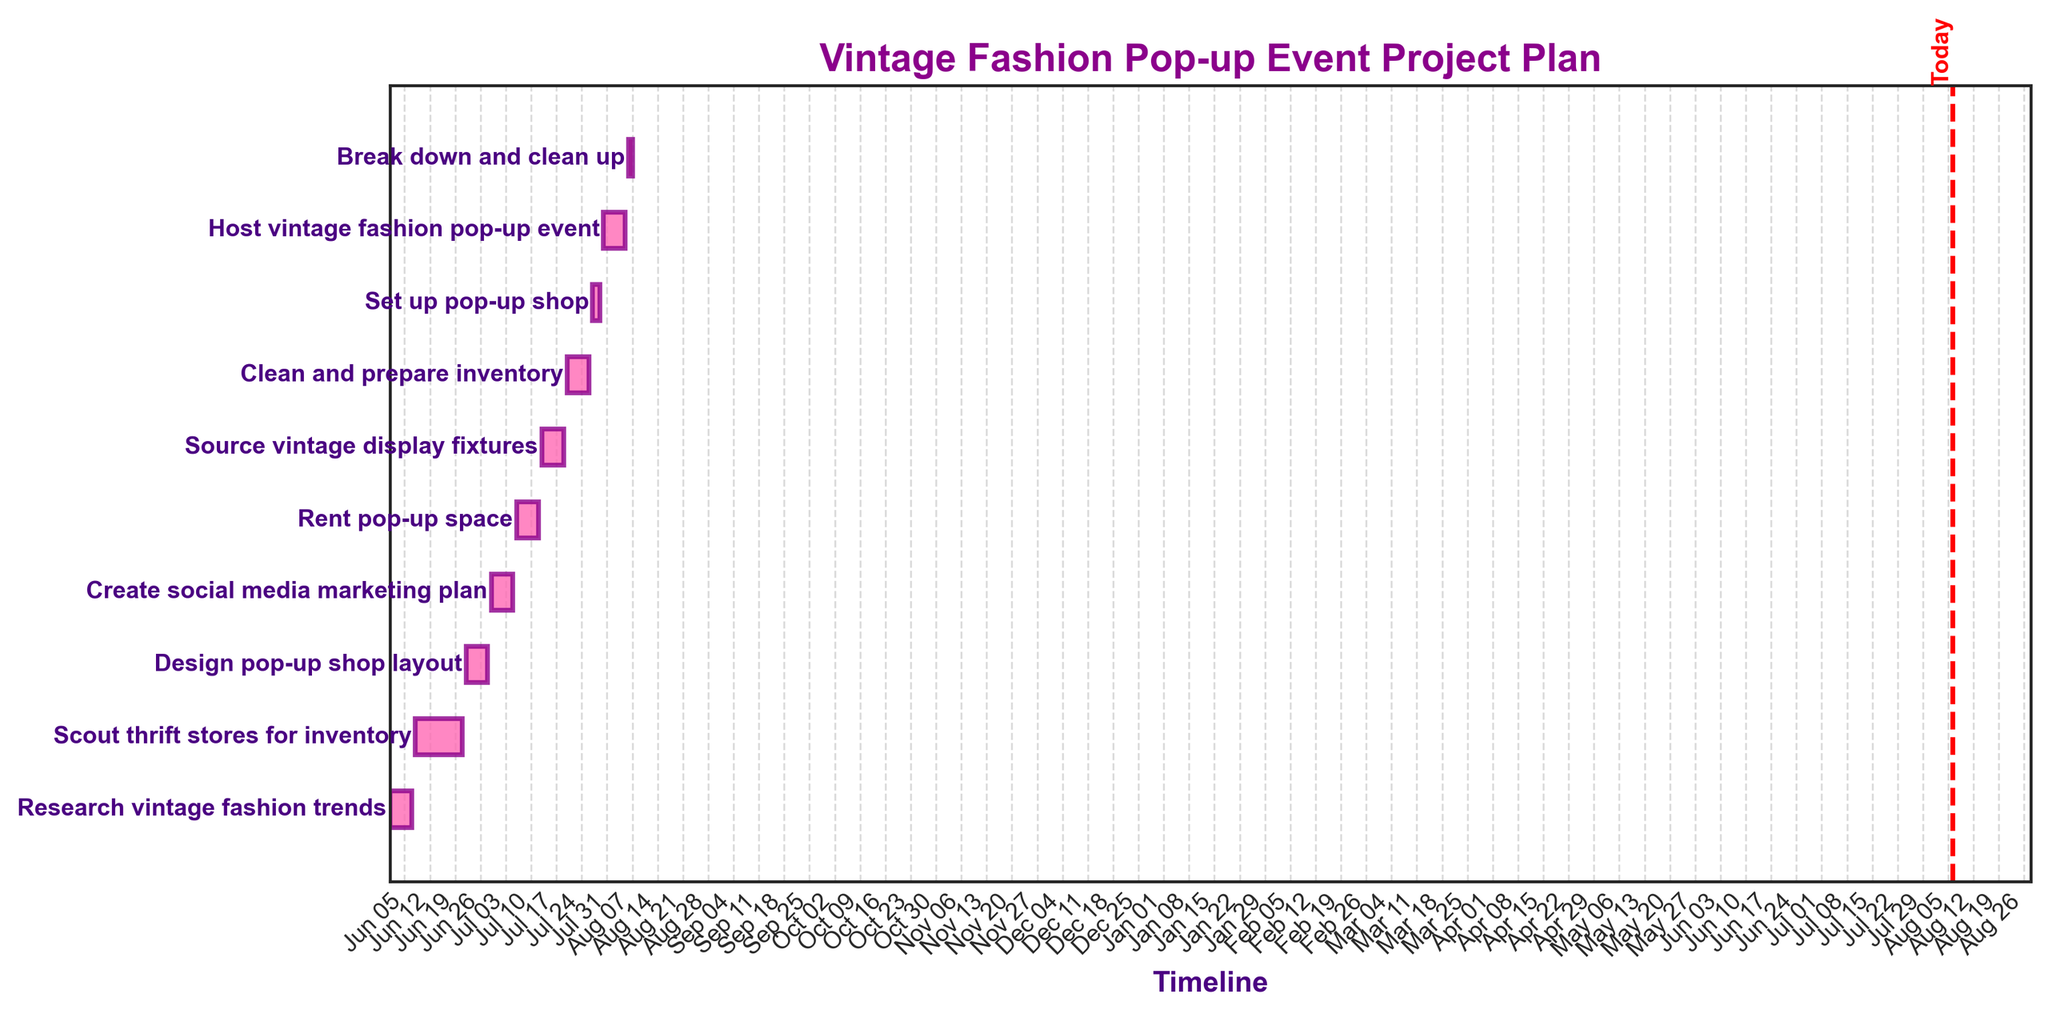What is the title of the chart? The title of the chart is located at the top and it clearly states the purpose of the Gantt chart.
Answer: Vintage Fashion Pop-up Event Project Plan How many total tasks are shown in the chart? By counting the number of horizontal bars in the Gantt chart, we can determine the total number of tasks involved in the project.
Answer: 10 Which task takes the longest duration to complete? By comparing the lengths of all the horizontal bars, we can see that "Scout thrift stores for inventory" spans the longest duration.
Answer: Scout thrift stores for inventory How many tasks have a duration of 7 days? By looking at the durations next to each task in the Gantt chart, we can count how many tasks are labeled with a duration of 7 days.
Answer: 6 What is the start and end date of the task "Set up pop-up shop"? By locating the "Set up pop-up shop" task in the chart, we can see its start date and end date on the horizontal timeline.
Answer: July 27 to July 29 Which two tasks are planned to be done simultaneously? By examining which horizontal bars overlap on the timeline, we can see that "Scout thrift stores for inventory" and "Design pop-up shop layout" partially overlap.
Answer: Scout thrift stores for inventory and Design pop-up shop layout How many days are included in the "Research vintage fashion trends" task? By analyzing the width of the bar corresponding to this task in the Gantt chart, we see that it starts on June 1 and ends on June 7, a total of 7 days.
Answer: 7 days What is the very last task to be completed according to the chart? By looking at the farthest right end of the Gantt chart, we can determine which task ends the latest.
Answer: Break down and clean up Which task ends just before the "Host vintage fashion pop-up event"? By examining the chart for the task that ends right before July 30, when the "Host vintage fashion pop-up event" starts, we find that "Set up pop-up shop" is the preceding task.
Answer: Set up pop-up shop When is today's date line drawn according to the chart? The red vertical line represents today's date. To find its position, we look for the line marked with the label "Today".
Answer: Today 